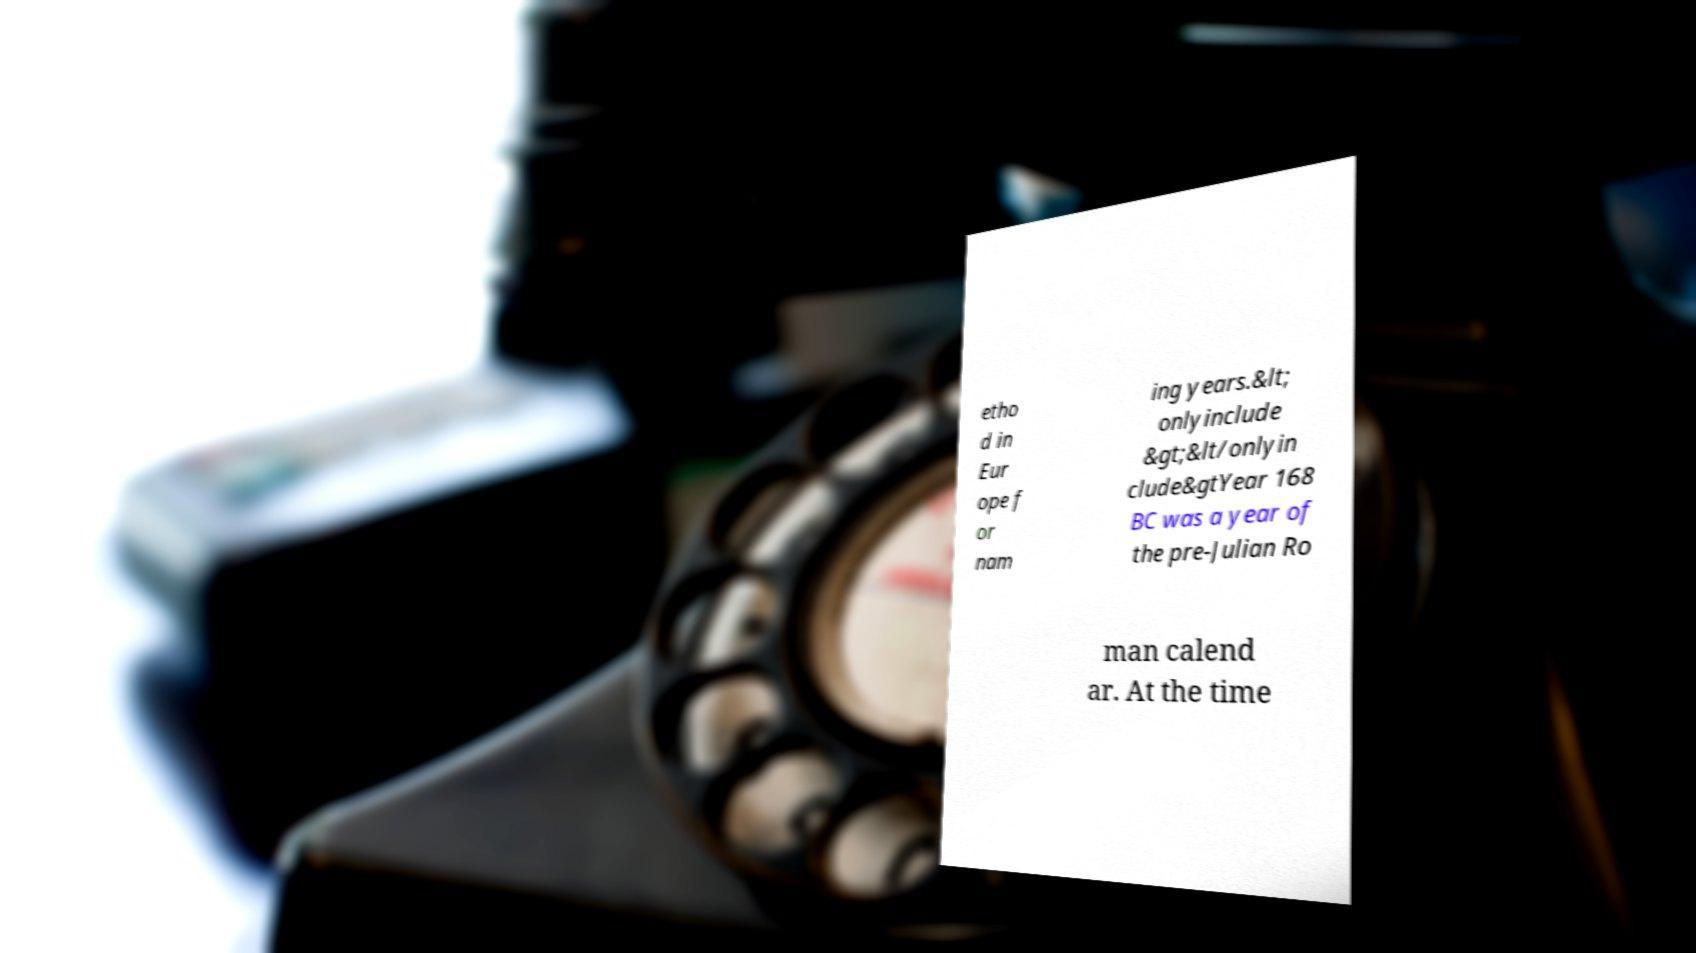For documentation purposes, I need the text within this image transcribed. Could you provide that? etho d in Eur ope f or nam ing years.&lt; onlyinclude &gt;&lt/onlyin clude&gtYear 168 BC was a year of the pre-Julian Ro man calend ar. At the time 